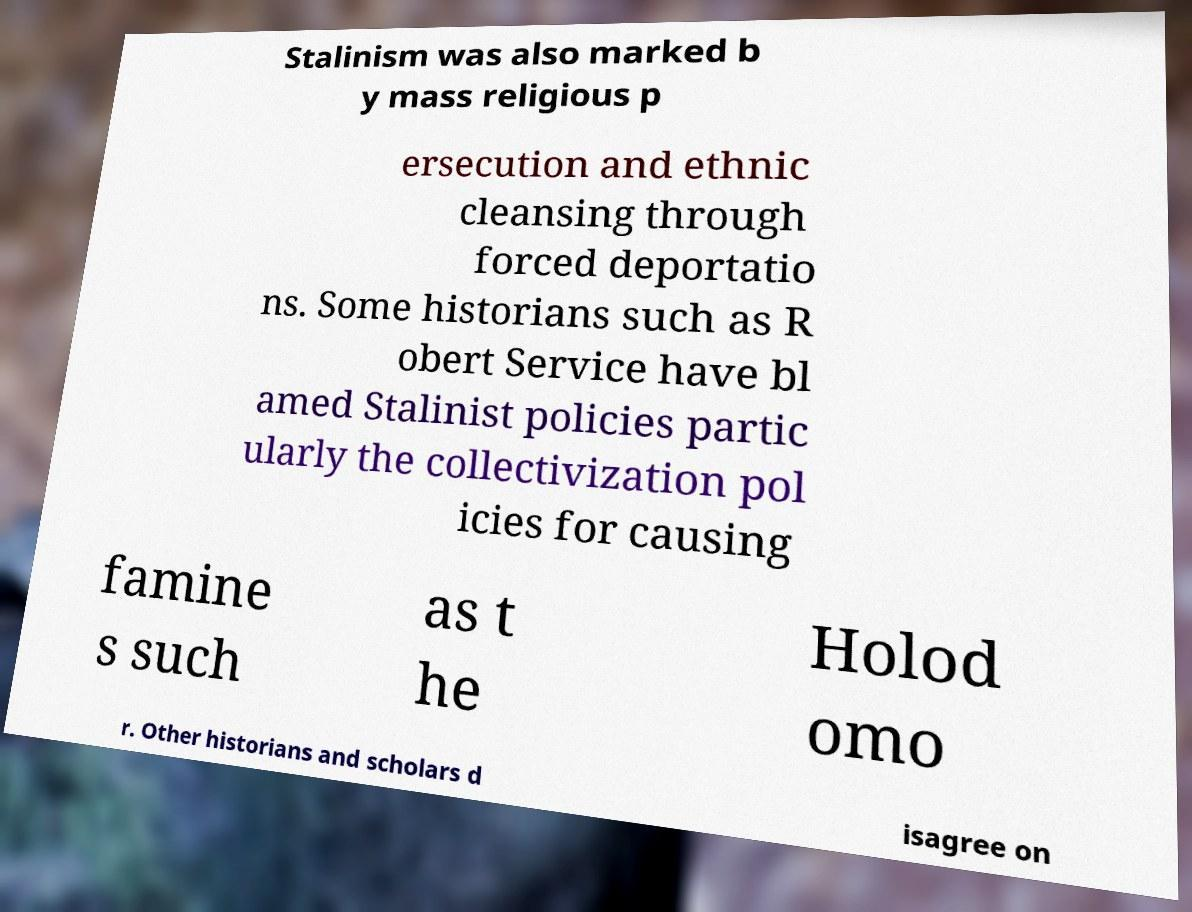Could you assist in decoding the text presented in this image and type it out clearly? Stalinism was also marked b y mass religious p ersecution and ethnic cleansing through forced deportatio ns. Some historians such as R obert Service have bl amed Stalinist policies partic ularly the collectivization pol icies for causing famine s such as t he Holod omo r. Other historians and scholars d isagree on 